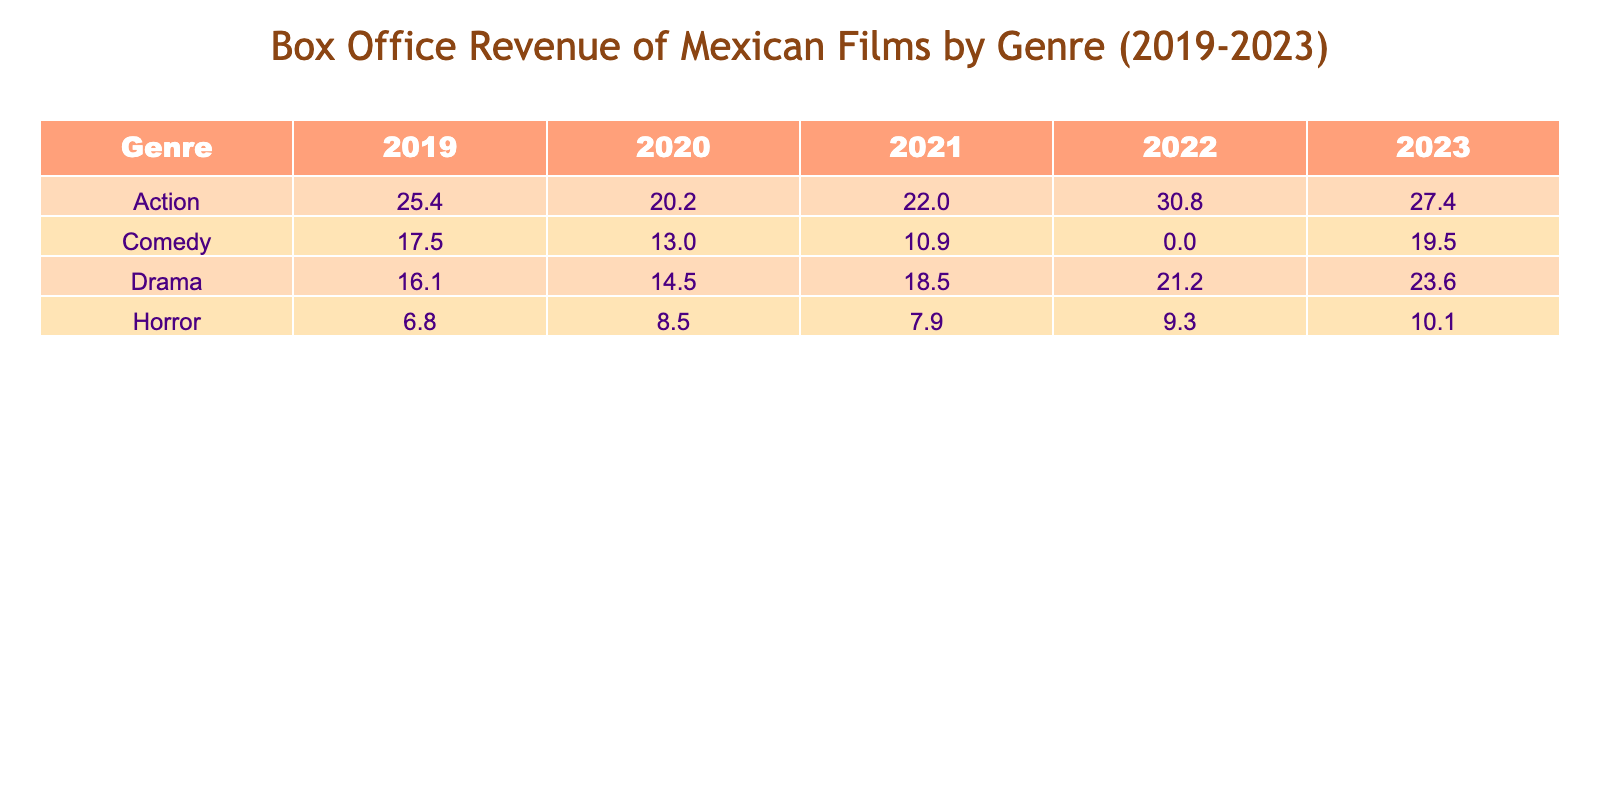What is the box office revenue for the Action genre in 2022? Looking at the table, the box office revenue for Action films in 2022 is listed as 30.8 million USD.
Answer: 30.8 million USD What is the total box office revenue for Comedy films over the years from 2019 to 2023? Adding the revenues: (17.5 + 13.0 + 10.9 + 19.5) = 61.0 million USD.
Answer: 61.0 million USD Did the Drama genre have a higher revenue in 2023 than in 2021? The Drama revenue in 2023 is 23.6 million USD and in 2021 it is 18.5 million USD; 23.6 > 18.5 is true.
Answer: Yes Which genre had the lowest box office revenue in 2019? The table shows that Horror films made 6.8 million USD in 2019, which is less than the other genres' revenues for that year.
Answer: Horror What is the average box office revenue for the Horror genre from 2019 to 2023? The revenues are: (6.8 + 8.5 + 7.9 + 9.3 + 10.1) = 42.6 million USD. Since there are 5 data points, the average is 42.6 / 5 = 8.52 million USD.
Answer: 8.52 million USD Which genre earned the most revenue in 2023? The Action genre topped the list with a revenue of 27.4 million USD in 2023, more than other genres for that year.
Answer: Action What is the increase in box office revenue for Action films from 2020 to 2022? The revenue for Action in 2020 is 20.2 million USD and in 2022 it is 30.8 million USD. The increase is 30.8 - 20.2 = 10.6 million USD.
Answer: 10.6 million USD In which year did the Action genre reach its peak revenue? By examining the table, Action films had their highest revenue of 30.8 million USD in 2022, which is greater than the revenues for other years.
Answer: 2022 What is the box office revenue difference between the Comedy and Drama genres in 2021? In 2021, Comedy made 10.9 million USD and Drama made 18.5 million USD. The difference is 18.5 - 10.9 = 7.6 million USD.
Answer: 7.6 million USD What was the total box office revenue for all genres in 2020? Summing the revenues from all genres in 2020 gives: 13.0 + 20.2 + 14.5 + 8.5 = 56.2 million USD.
Answer: 56.2 million USD 